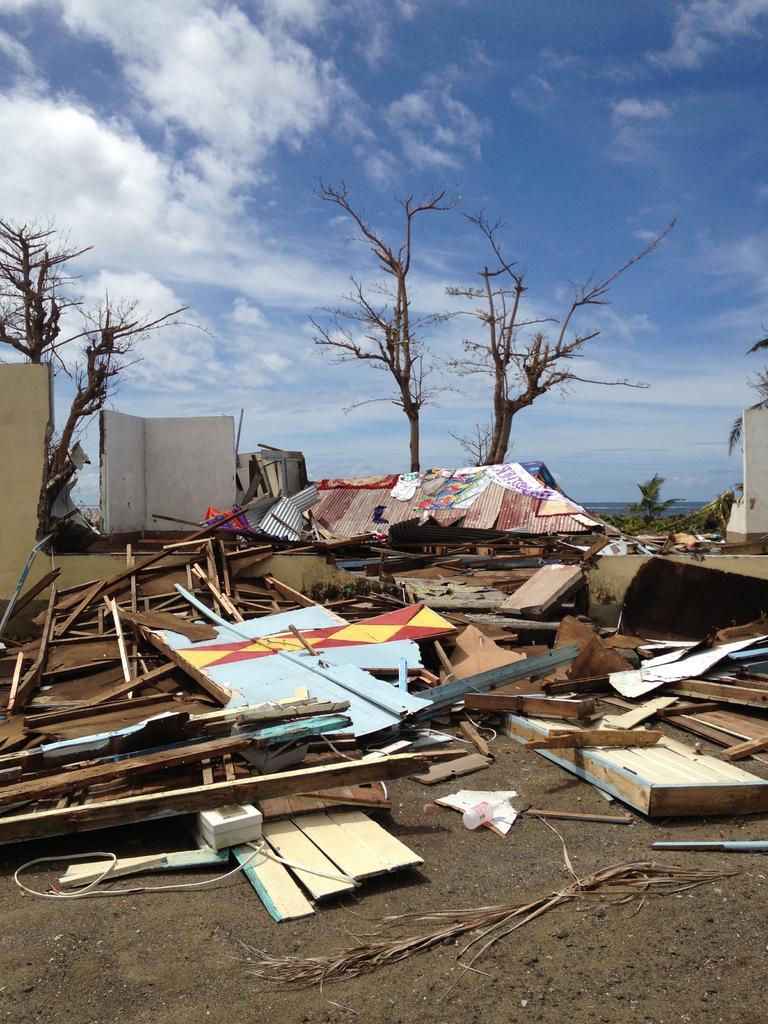In one or two sentences, can you explain what this image depicts? In this picture we can see some wooden sticks on the floor, trees and sky. 